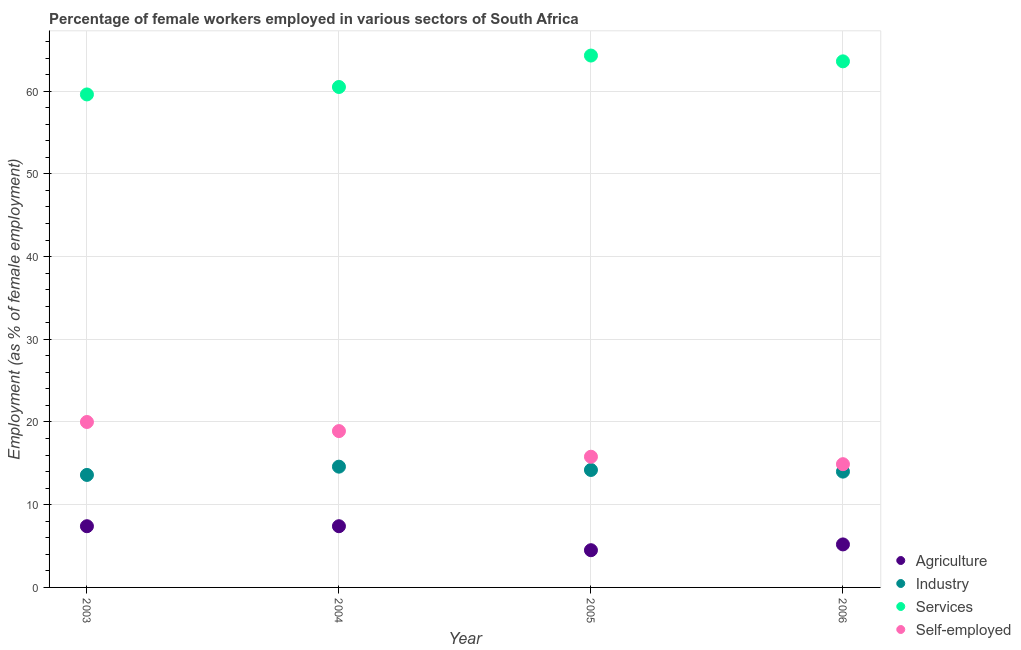Is the number of dotlines equal to the number of legend labels?
Make the answer very short. Yes. What is the percentage of self employed female workers in 2005?
Offer a terse response. 15.8. Across all years, what is the maximum percentage of female workers in agriculture?
Offer a terse response. 7.4. Across all years, what is the minimum percentage of female workers in industry?
Ensure brevity in your answer.  13.6. In which year was the percentage of female workers in services minimum?
Offer a terse response. 2003. What is the total percentage of self employed female workers in the graph?
Your answer should be very brief. 69.6. What is the difference between the percentage of female workers in agriculture in 2004 and that in 2005?
Ensure brevity in your answer.  2.9. What is the difference between the percentage of female workers in services in 2003 and the percentage of female workers in industry in 2004?
Your answer should be very brief. 45. What is the average percentage of female workers in industry per year?
Keep it short and to the point. 14.1. In the year 2004, what is the difference between the percentage of female workers in services and percentage of female workers in agriculture?
Provide a short and direct response. 53.1. What is the ratio of the percentage of female workers in industry in 2003 to that in 2006?
Make the answer very short. 0.97. Is the difference between the percentage of self employed female workers in 2003 and 2005 greater than the difference between the percentage of female workers in services in 2003 and 2005?
Offer a terse response. Yes. What is the difference between the highest and the second highest percentage of self employed female workers?
Give a very brief answer. 1.1. What is the difference between the highest and the lowest percentage of self employed female workers?
Keep it short and to the point. 5.1. In how many years, is the percentage of self employed female workers greater than the average percentage of self employed female workers taken over all years?
Keep it short and to the point. 2. Is the sum of the percentage of self employed female workers in 2003 and 2006 greater than the maximum percentage of female workers in industry across all years?
Your answer should be compact. Yes. Is it the case that in every year, the sum of the percentage of female workers in industry and percentage of female workers in agriculture is greater than the sum of percentage of self employed female workers and percentage of female workers in services?
Provide a short and direct response. No. Is it the case that in every year, the sum of the percentage of female workers in agriculture and percentage of female workers in industry is greater than the percentage of female workers in services?
Offer a terse response. No. How many dotlines are there?
Provide a short and direct response. 4. How many years are there in the graph?
Make the answer very short. 4. What is the difference between two consecutive major ticks on the Y-axis?
Provide a succinct answer. 10. Does the graph contain any zero values?
Provide a short and direct response. No. Where does the legend appear in the graph?
Your answer should be compact. Bottom right. What is the title of the graph?
Provide a short and direct response. Percentage of female workers employed in various sectors of South Africa. Does "Building human resources" appear as one of the legend labels in the graph?
Provide a succinct answer. No. What is the label or title of the X-axis?
Offer a terse response. Year. What is the label or title of the Y-axis?
Your answer should be very brief. Employment (as % of female employment). What is the Employment (as % of female employment) in Agriculture in 2003?
Offer a very short reply. 7.4. What is the Employment (as % of female employment) in Industry in 2003?
Offer a very short reply. 13.6. What is the Employment (as % of female employment) in Services in 2003?
Offer a terse response. 59.6. What is the Employment (as % of female employment) of Self-employed in 2003?
Your answer should be compact. 20. What is the Employment (as % of female employment) in Agriculture in 2004?
Offer a very short reply. 7.4. What is the Employment (as % of female employment) of Industry in 2004?
Keep it short and to the point. 14.6. What is the Employment (as % of female employment) in Services in 2004?
Your answer should be compact. 60.5. What is the Employment (as % of female employment) of Self-employed in 2004?
Give a very brief answer. 18.9. What is the Employment (as % of female employment) of Agriculture in 2005?
Make the answer very short. 4.5. What is the Employment (as % of female employment) in Industry in 2005?
Offer a terse response. 14.2. What is the Employment (as % of female employment) of Services in 2005?
Your answer should be very brief. 64.3. What is the Employment (as % of female employment) of Self-employed in 2005?
Your answer should be compact. 15.8. What is the Employment (as % of female employment) of Agriculture in 2006?
Your answer should be very brief. 5.2. What is the Employment (as % of female employment) in Services in 2006?
Your answer should be very brief. 63.6. What is the Employment (as % of female employment) of Self-employed in 2006?
Offer a terse response. 14.9. Across all years, what is the maximum Employment (as % of female employment) in Agriculture?
Ensure brevity in your answer.  7.4. Across all years, what is the maximum Employment (as % of female employment) of Industry?
Keep it short and to the point. 14.6. Across all years, what is the maximum Employment (as % of female employment) of Services?
Your response must be concise. 64.3. Across all years, what is the maximum Employment (as % of female employment) of Self-employed?
Your response must be concise. 20. Across all years, what is the minimum Employment (as % of female employment) of Industry?
Provide a short and direct response. 13.6. Across all years, what is the minimum Employment (as % of female employment) in Services?
Your response must be concise. 59.6. Across all years, what is the minimum Employment (as % of female employment) in Self-employed?
Give a very brief answer. 14.9. What is the total Employment (as % of female employment) of Industry in the graph?
Your answer should be compact. 56.4. What is the total Employment (as % of female employment) in Services in the graph?
Ensure brevity in your answer.  248. What is the total Employment (as % of female employment) of Self-employed in the graph?
Offer a terse response. 69.6. What is the difference between the Employment (as % of female employment) of Agriculture in 2003 and that in 2004?
Offer a terse response. 0. What is the difference between the Employment (as % of female employment) of Industry in 2003 and that in 2004?
Your answer should be compact. -1. What is the difference between the Employment (as % of female employment) of Services in 2003 and that in 2004?
Your answer should be very brief. -0.9. What is the difference between the Employment (as % of female employment) of Agriculture in 2003 and that in 2005?
Offer a terse response. 2.9. What is the difference between the Employment (as % of female employment) of Self-employed in 2003 and that in 2005?
Make the answer very short. 4.2. What is the difference between the Employment (as % of female employment) of Industry in 2003 and that in 2006?
Ensure brevity in your answer.  -0.4. What is the difference between the Employment (as % of female employment) in Self-employed in 2003 and that in 2006?
Ensure brevity in your answer.  5.1. What is the difference between the Employment (as % of female employment) in Industry in 2004 and that in 2005?
Your answer should be compact. 0.4. What is the difference between the Employment (as % of female employment) in Self-employed in 2004 and that in 2005?
Offer a terse response. 3.1. What is the difference between the Employment (as % of female employment) of Agriculture in 2004 and that in 2006?
Make the answer very short. 2.2. What is the difference between the Employment (as % of female employment) in Industry in 2004 and that in 2006?
Offer a very short reply. 0.6. What is the difference between the Employment (as % of female employment) in Services in 2005 and that in 2006?
Give a very brief answer. 0.7. What is the difference between the Employment (as % of female employment) in Agriculture in 2003 and the Employment (as % of female employment) in Services in 2004?
Ensure brevity in your answer.  -53.1. What is the difference between the Employment (as % of female employment) in Industry in 2003 and the Employment (as % of female employment) in Services in 2004?
Provide a short and direct response. -46.9. What is the difference between the Employment (as % of female employment) in Services in 2003 and the Employment (as % of female employment) in Self-employed in 2004?
Offer a very short reply. 40.7. What is the difference between the Employment (as % of female employment) in Agriculture in 2003 and the Employment (as % of female employment) in Services in 2005?
Ensure brevity in your answer.  -56.9. What is the difference between the Employment (as % of female employment) in Industry in 2003 and the Employment (as % of female employment) in Services in 2005?
Provide a succinct answer. -50.7. What is the difference between the Employment (as % of female employment) in Services in 2003 and the Employment (as % of female employment) in Self-employed in 2005?
Your answer should be very brief. 43.8. What is the difference between the Employment (as % of female employment) in Agriculture in 2003 and the Employment (as % of female employment) in Services in 2006?
Keep it short and to the point. -56.2. What is the difference between the Employment (as % of female employment) of Industry in 2003 and the Employment (as % of female employment) of Services in 2006?
Ensure brevity in your answer.  -50. What is the difference between the Employment (as % of female employment) in Services in 2003 and the Employment (as % of female employment) in Self-employed in 2006?
Offer a very short reply. 44.7. What is the difference between the Employment (as % of female employment) in Agriculture in 2004 and the Employment (as % of female employment) in Industry in 2005?
Your response must be concise. -6.8. What is the difference between the Employment (as % of female employment) in Agriculture in 2004 and the Employment (as % of female employment) in Services in 2005?
Offer a very short reply. -56.9. What is the difference between the Employment (as % of female employment) in Agriculture in 2004 and the Employment (as % of female employment) in Self-employed in 2005?
Offer a very short reply. -8.4. What is the difference between the Employment (as % of female employment) in Industry in 2004 and the Employment (as % of female employment) in Services in 2005?
Your answer should be very brief. -49.7. What is the difference between the Employment (as % of female employment) of Services in 2004 and the Employment (as % of female employment) of Self-employed in 2005?
Your answer should be very brief. 44.7. What is the difference between the Employment (as % of female employment) in Agriculture in 2004 and the Employment (as % of female employment) in Industry in 2006?
Provide a short and direct response. -6.6. What is the difference between the Employment (as % of female employment) of Agriculture in 2004 and the Employment (as % of female employment) of Services in 2006?
Keep it short and to the point. -56.2. What is the difference between the Employment (as % of female employment) of Agriculture in 2004 and the Employment (as % of female employment) of Self-employed in 2006?
Provide a short and direct response. -7.5. What is the difference between the Employment (as % of female employment) of Industry in 2004 and the Employment (as % of female employment) of Services in 2006?
Offer a terse response. -49. What is the difference between the Employment (as % of female employment) in Industry in 2004 and the Employment (as % of female employment) in Self-employed in 2006?
Your answer should be compact. -0.3. What is the difference between the Employment (as % of female employment) of Services in 2004 and the Employment (as % of female employment) of Self-employed in 2006?
Ensure brevity in your answer.  45.6. What is the difference between the Employment (as % of female employment) of Agriculture in 2005 and the Employment (as % of female employment) of Services in 2006?
Keep it short and to the point. -59.1. What is the difference between the Employment (as % of female employment) of Agriculture in 2005 and the Employment (as % of female employment) of Self-employed in 2006?
Offer a very short reply. -10.4. What is the difference between the Employment (as % of female employment) of Industry in 2005 and the Employment (as % of female employment) of Services in 2006?
Your response must be concise. -49.4. What is the difference between the Employment (as % of female employment) in Industry in 2005 and the Employment (as % of female employment) in Self-employed in 2006?
Make the answer very short. -0.7. What is the difference between the Employment (as % of female employment) of Services in 2005 and the Employment (as % of female employment) of Self-employed in 2006?
Your answer should be very brief. 49.4. What is the average Employment (as % of female employment) in Agriculture per year?
Offer a terse response. 6.12. What is the average Employment (as % of female employment) in Industry per year?
Your response must be concise. 14.1. What is the average Employment (as % of female employment) of Services per year?
Make the answer very short. 62. What is the average Employment (as % of female employment) in Self-employed per year?
Your response must be concise. 17.4. In the year 2003, what is the difference between the Employment (as % of female employment) of Agriculture and Employment (as % of female employment) of Services?
Offer a very short reply. -52.2. In the year 2003, what is the difference between the Employment (as % of female employment) in Agriculture and Employment (as % of female employment) in Self-employed?
Provide a short and direct response. -12.6. In the year 2003, what is the difference between the Employment (as % of female employment) of Industry and Employment (as % of female employment) of Services?
Your answer should be very brief. -46. In the year 2003, what is the difference between the Employment (as % of female employment) of Services and Employment (as % of female employment) of Self-employed?
Offer a very short reply. 39.6. In the year 2004, what is the difference between the Employment (as % of female employment) of Agriculture and Employment (as % of female employment) of Services?
Give a very brief answer. -53.1. In the year 2004, what is the difference between the Employment (as % of female employment) of Industry and Employment (as % of female employment) of Services?
Ensure brevity in your answer.  -45.9. In the year 2004, what is the difference between the Employment (as % of female employment) in Services and Employment (as % of female employment) in Self-employed?
Ensure brevity in your answer.  41.6. In the year 2005, what is the difference between the Employment (as % of female employment) of Agriculture and Employment (as % of female employment) of Services?
Provide a succinct answer. -59.8. In the year 2005, what is the difference between the Employment (as % of female employment) in Agriculture and Employment (as % of female employment) in Self-employed?
Provide a succinct answer. -11.3. In the year 2005, what is the difference between the Employment (as % of female employment) in Industry and Employment (as % of female employment) in Services?
Your answer should be compact. -50.1. In the year 2005, what is the difference between the Employment (as % of female employment) of Industry and Employment (as % of female employment) of Self-employed?
Give a very brief answer. -1.6. In the year 2005, what is the difference between the Employment (as % of female employment) of Services and Employment (as % of female employment) of Self-employed?
Offer a terse response. 48.5. In the year 2006, what is the difference between the Employment (as % of female employment) of Agriculture and Employment (as % of female employment) of Services?
Provide a short and direct response. -58.4. In the year 2006, what is the difference between the Employment (as % of female employment) in Industry and Employment (as % of female employment) in Services?
Keep it short and to the point. -49.6. In the year 2006, what is the difference between the Employment (as % of female employment) in Industry and Employment (as % of female employment) in Self-employed?
Give a very brief answer. -0.9. In the year 2006, what is the difference between the Employment (as % of female employment) in Services and Employment (as % of female employment) in Self-employed?
Your response must be concise. 48.7. What is the ratio of the Employment (as % of female employment) of Industry in 2003 to that in 2004?
Make the answer very short. 0.93. What is the ratio of the Employment (as % of female employment) in Services in 2003 to that in 2004?
Ensure brevity in your answer.  0.99. What is the ratio of the Employment (as % of female employment) of Self-employed in 2003 to that in 2004?
Make the answer very short. 1.06. What is the ratio of the Employment (as % of female employment) of Agriculture in 2003 to that in 2005?
Your response must be concise. 1.64. What is the ratio of the Employment (as % of female employment) in Industry in 2003 to that in 2005?
Offer a terse response. 0.96. What is the ratio of the Employment (as % of female employment) in Services in 2003 to that in 2005?
Your answer should be compact. 0.93. What is the ratio of the Employment (as % of female employment) in Self-employed in 2003 to that in 2005?
Provide a short and direct response. 1.27. What is the ratio of the Employment (as % of female employment) of Agriculture in 2003 to that in 2006?
Your response must be concise. 1.42. What is the ratio of the Employment (as % of female employment) of Industry in 2003 to that in 2006?
Ensure brevity in your answer.  0.97. What is the ratio of the Employment (as % of female employment) of Services in 2003 to that in 2006?
Your answer should be very brief. 0.94. What is the ratio of the Employment (as % of female employment) in Self-employed in 2003 to that in 2006?
Keep it short and to the point. 1.34. What is the ratio of the Employment (as % of female employment) of Agriculture in 2004 to that in 2005?
Offer a terse response. 1.64. What is the ratio of the Employment (as % of female employment) of Industry in 2004 to that in 2005?
Ensure brevity in your answer.  1.03. What is the ratio of the Employment (as % of female employment) of Services in 2004 to that in 2005?
Keep it short and to the point. 0.94. What is the ratio of the Employment (as % of female employment) of Self-employed in 2004 to that in 2005?
Offer a terse response. 1.2. What is the ratio of the Employment (as % of female employment) of Agriculture in 2004 to that in 2006?
Provide a succinct answer. 1.42. What is the ratio of the Employment (as % of female employment) in Industry in 2004 to that in 2006?
Offer a very short reply. 1.04. What is the ratio of the Employment (as % of female employment) in Services in 2004 to that in 2006?
Ensure brevity in your answer.  0.95. What is the ratio of the Employment (as % of female employment) of Self-employed in 2004 to that in 2006?
Keep it short and to the point. 1.27. What is the ratio of the Employment (as % of female employment) of Agriculture in 2005 to that in 2006?
Keep it short and to the point. 0.87. What is the ratio of the Employment (as % of female employment) of Industry in 2005 to that in 2006?
Offer a very short reply. 1.01. What is the ratio of the Employment (as % of female employment) in Services in 2005 to that in 2006?
Make the answer very short. 1.01. What is the ratio of the Employment (as % of female employment) in Self-employed in 2005 to that in 2006?
Your response must be concise. 1.06. What is the difference between the highest and the second highest Employment (as % of female employment) of Industry?
Your response must be concise. 0.4. What is the difference between the highest and the lowest Employment (as % of female employment) of Agriculture?
Your answer should be very brief. 2.9. 